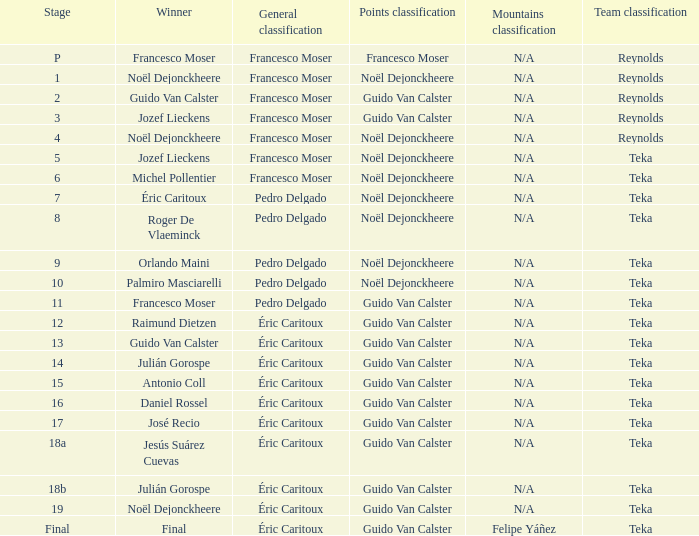Name the points classification of stage 16 Guido Van Calster. 